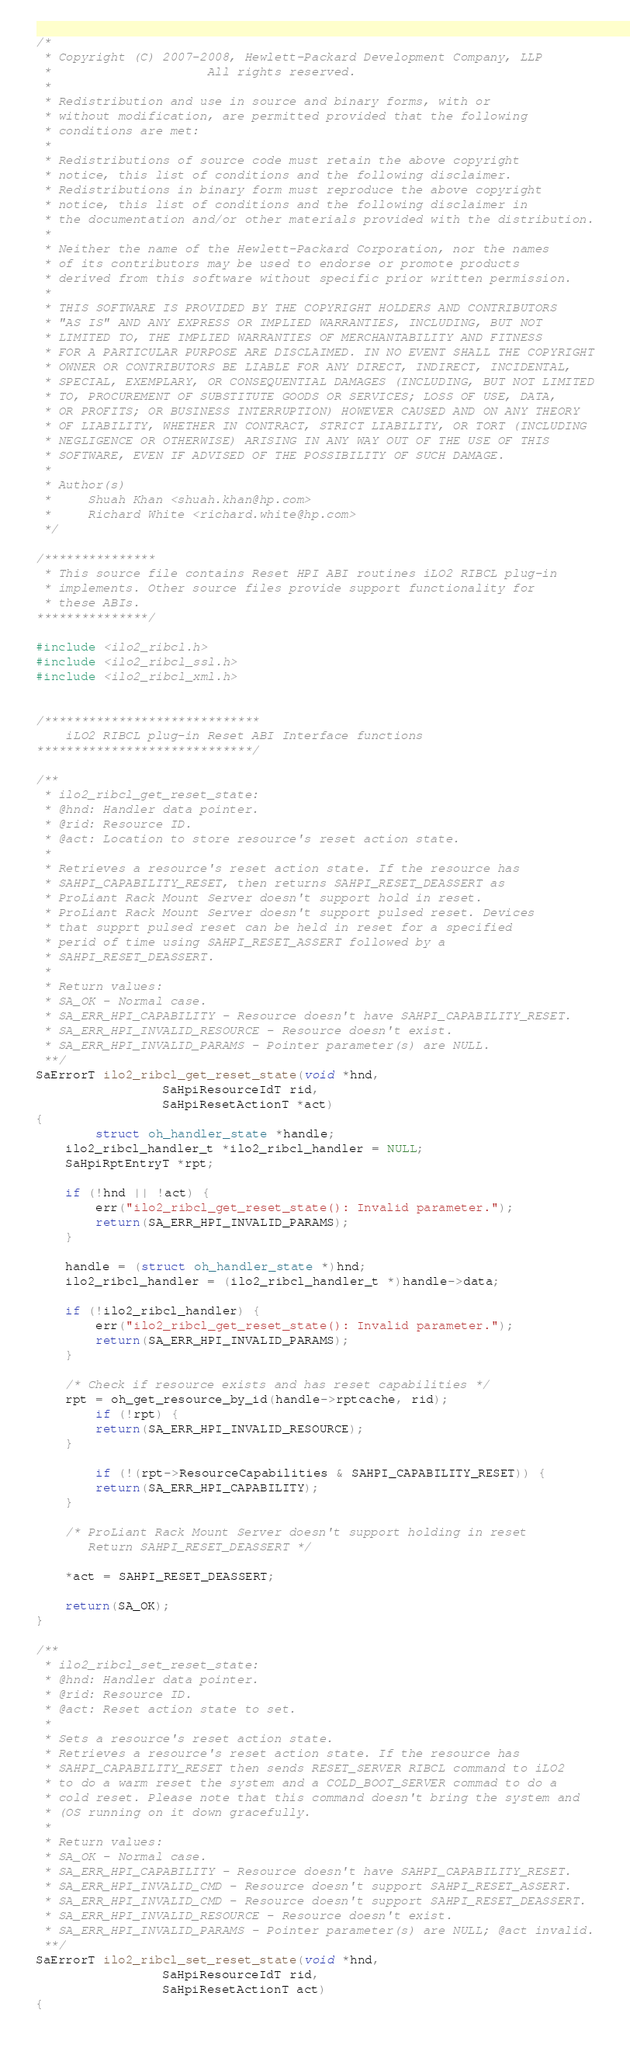<code> <loc_0><loc_0><loc_500><loc_500><_C_>/*
 * Copyright (C) 2007-2008, Hewlett-Packard Development Company, LLP
 *                     All rights reserved.
 *
 * Redistribution and use in source and binary forms, with or
 * without modification, are permitted provided that the following
 * conditions are met:
 *
 * Redistributions of source code must retain the above copyright
 * notice, this list of conditions and the following disclaimer.
 * Redistributions in binary form must reproduce the above copyright
 * notice, this list of conditions and the following disclaimer in
 * the documentation and/or other materials provided with the distribution.
 *
 * Neither the name of the Hewlett-Packard Corporation, nor the names
 * of its contributors may be used to endorse or promote products
 * derived from this software without specific prior written permission.
 *
 * THIS SOFTWARE IS PROVIDED BY THE COPYRIGHT HOLDERS AND CONTRIBUTORS
 * "AS IS" AND ANY EXPRESS OR IMPLIED WARRANTIES, INCLUDING, BUT NOT
 * LIMITED TO, THE IMPLIED WARRANTIES OF MERCHANTABILITY AND FITNESS
 * FOR A PARTICULAR PURPOSE ARE DISCLAIMED. IN NO EVENT SHALL THE COPYRIGHT
 * OWNER OR CONTRIBUTORS BE LIABLE FOR ANY DIRECT, INDIRECT, INCIDENTAL,
 * SPECIAL, EXEMPLARY, OR CONSEQUENTIAL DAMAGES (INCLUDING, BUT NOT LIMITED
 * TO, PROCUREMENT OF SUBSTITUTE GOODS OR SERVICES; LOSS OF USE, DATA,
 * OR PROFITS; OR BUSINESS INTERRUPTION) HOWEVER CAUSED AND ON ANY THEORY
 * OF LIABILITY, WHETHER IN CONTRACT, STRICT LIABILITY, OR TORT (INCLUDING
 * NEGLIGENCE OR OTHERWISE) ARISING IN ANY WAY OUT OF THE USE OF THIS
 * SOFTWARE, EVEN IF ADVISED OF THE POSSIBILITY OF SUCH DAMAGE.
 *
 * Author(s)
 *     Shuah Khan <shuah.khan@hp.com>
 *     Richard White <richard.white@hp.com>
 */

/***************
 * This source file contains Reset HPI ABI routines iLO2 RIBCL plug-in
 * implements. Other source files provide support functionality for
 * these ABIs.
***************/

#include <ilo2_ribcl.h>
#include <ilo2_ribcl_ssl.h>
#include <ilo2_ribcl_xml.h>


/*****************************
	iLO2 RIBCL plug-in Reset ABI Interface functions
*****************************/

/**
 * ilo2_ribcl_get_reset_state:
 * @hnd: Handler data pointer.
 * @rid: Resource ID.
 * @act: Location to store resource's reset action state.
 *
 * Retrieves a resource's reset action state. If the resource has
 * SAHPI_CAPABILITY_RESET, then returns SAHPI_RESET_DEASSERT as
 * ProLiant Rack Mount Server doesn't support hold in reset.
 * ProLiant Rack Mount Server doesn't support pulsed reset. Devices
 * that supprt pulsed reset can be held in reset for a specified 
 * perid of time using SAHPI_RESET_ASSERT followed by a
 * SAHPI_RESET_DEASSERT.
 *
 * Return values:
 * SA_OK - Normal case.
 * SA_ERR_HPI_CAPABILITY - Resource doesn't have SAHPI_CAPABILITY_RESET.
 * SA_ERR_HPI_INVALID_RESOURCE - Resource doesn't exist.
 * SA_ERR_HPI_INVALID_PARAMS - Pointer parameter(s) are NULL.
 **/
SaErrorT ilo2_ribcl_get_reset_state(void *hnd,
				 SaHpiResourceIdT rid,
				 SaHpiResetActionT *act)
{
        struct oh_handler_state *handle;
	ilo2_ribcl_handler_t *ilo2_ribcl_handler = NULL;
	SaHpiRptEntryT *rpt;

	if (!hnd || !act) {
		err("ilo2_ribcl_get_reset_state(): Invalid parameter.");
		return(SA_ERR_HPI_INVALID_PARAMS);
	}

	handle = (struct oh_handler_state *)hnd;
	ilo2_ribcl_handler = (ilo2_ribcl_handler_t *)handle->data;
	
	if (!ilo2_ribcl_handler) {
		err("ilo2_ribcl_get_reset_state(): Invalid parameter.");
		return(SA_ERR_HPI_INVALID_PARAMS);
	}

	/* Check if resource exists and has reset capabilities */
	rpt = oh_get_resource_by_id(handle->rptcache, rid);
        if (!rpt) {
		return(SA_ERR_HPI_INVALID_RESOURCE);
	} 
	
        if (!(rpt->ResourceCapabilities & SAHPI_CAPABILITY_RESET)) {
		return(SA_ERR_HPI_CAPABILITY);
	}

	/* ProLiant Rack Mount Server doesn't support holding in reset
	   Return SAHPI_RESET_DEASSERT */

	*act = SAHPI_RESET_DEASSERT;

	return(SA_OK);
}

/**
 * ilo2_ribcl_set_reset_state:
 * @hnd: Handler data pointer.
 * @rid: Resource ID.
 * @act: Reset action state to set.
 *
 * Sets a resource's reset action state.
 * Retrieves a resource's reset action state. If the resource has
 * SAHPI_CAPABILITY_RESET then sends RESET_SERVER RIBCL command to iLO2
 * to do a warm reset the system and a COLD_BOOT_SERVER commad to do a
 * cold reset. Please note that this command doesn't bring the system and
 * (OS running on it down gracefully.
 *
 * Return values:
 * SA_OK - Normal case.
 * SA_ERR_HPI_CAPABILITY - Resource doesn't have SAHPI_CAPABILITY_RESET.
 * SA_ERR_HPI_INVALID_CMD - Resource doesn't support SAHPI_RESET_ASSERT.
 * SA_ERR_HPI_INVALID_CMD - Resource doesn't support SAHPI_RESET_DEASSERT.
 * SA_ERR_HPI_INVALID_RESOURCE - Resource doesn't exist.
 * SA_ERR_HPI_INVALID_PARAMS - Pointer parameter(s) are NULL; @act invalid.
 **/
SaErrorT ilo2_ribcl_set_reset_state(void *hnd,
				 SaHpiResourceIdT rid,
				 SaHpiResetActionT act)
{</code> 